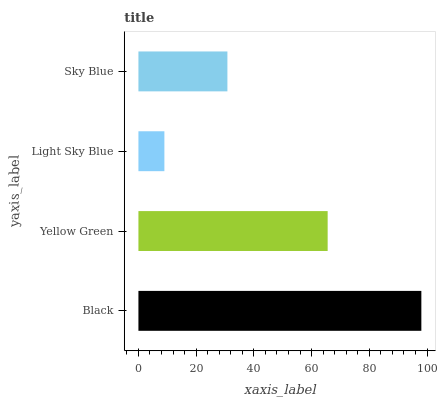Is Light Sky Blue the minimum?
Answer yes or no. Yes. Is Black the maximum?
Answer yes or no. Yes. Is Yellow Green the minimum?
Answer yes or no. No. Is Yellow Green the maximum?
Answer yes or no. No. Is Black greater than Yellow Green?
Answer yes or no. Yes. Is Yellow Green less than Black?
Answer yes or no. Yes. Is Yellow Green greater than Black?
Answer yes or no. No. Is Black less than Yellow Green?
Answer yes or no. No. Is Yellow Green the high median?
Answer yes or no. Yes. Is Sky Blue the low median?
Answer yes or no. Yes. Is Black the high median?
Answer yes or no. No. Is Black the low median?
Answer yes or no. No. 